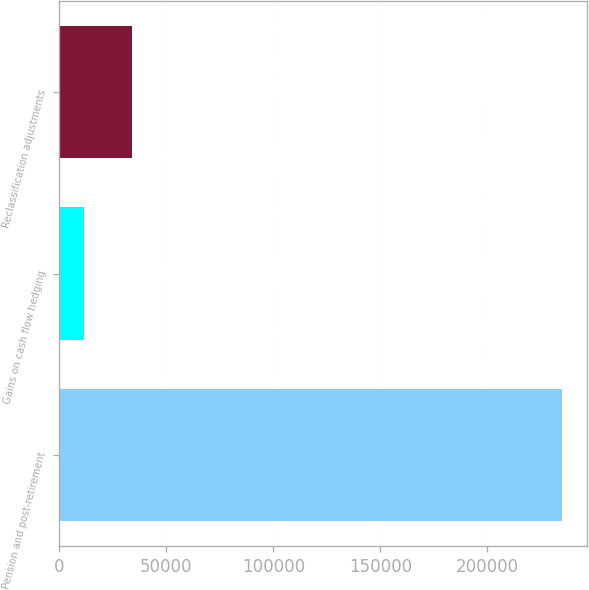Convert chart to OTSL. <chart><loc_0><loc_0><loc_500><loc_500><bar_chart><fcel>Pension and post-retirement<fcel>Gains on cash flow hedging<fcel>Reclassification adjustments<nl><fcel>234788<fcel>11496<fcel>34074<nl></chart> 